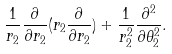Convert formula to latex. <formula><loc_0><loc_0><loc_500><loc_500>\frac { 1 } { r _ { 2 } } \frac { \partial } { \partial r _ { 2 } } ( r _ { 2 } \frac { \partial } { \partial r _ { 2 } } ) + \frac { 1 } { r _ { 2 } ^ { 2 } } \frac { \partial ^ { 2 } } { \partial \theta _ { 2 } ^ { 2 } } .</formula> 